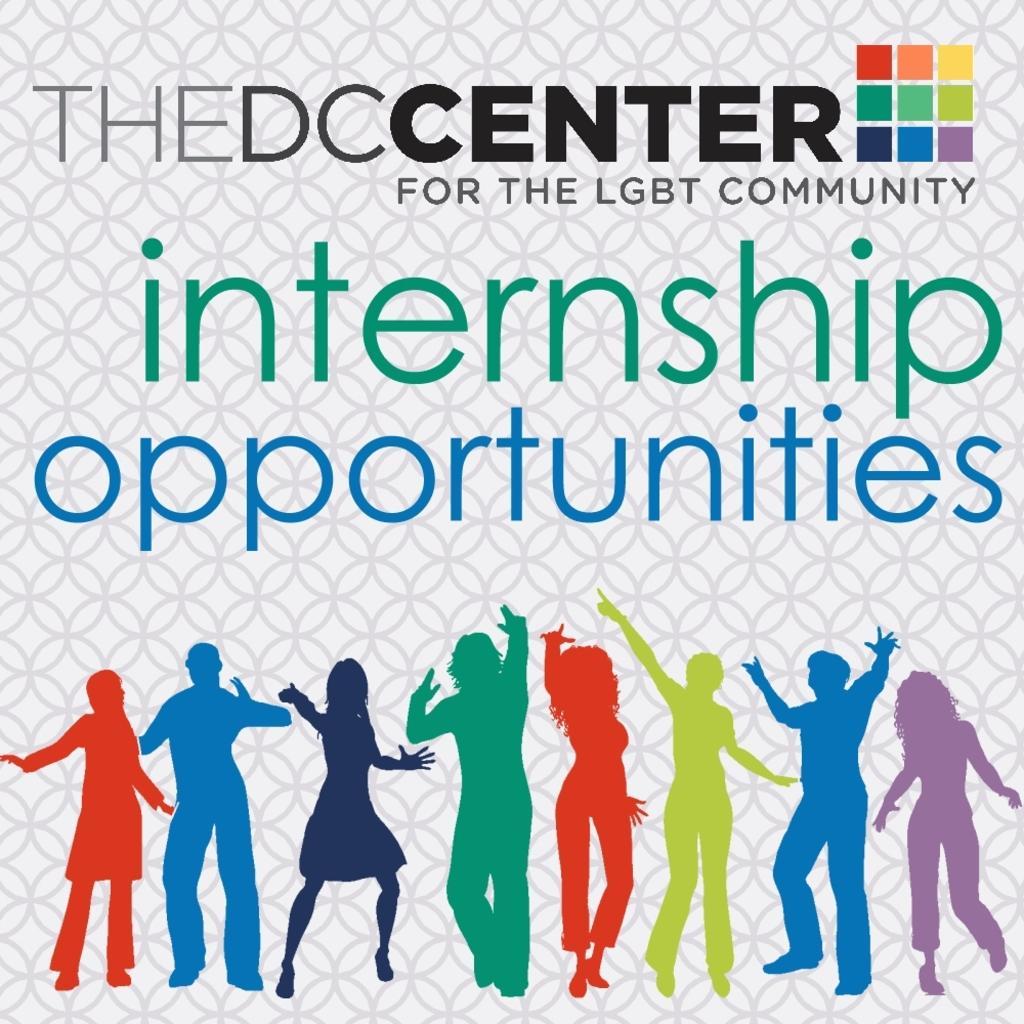Please provide a concise description of this image. This is a poster. Few people in this poster are representing LGBT community. 